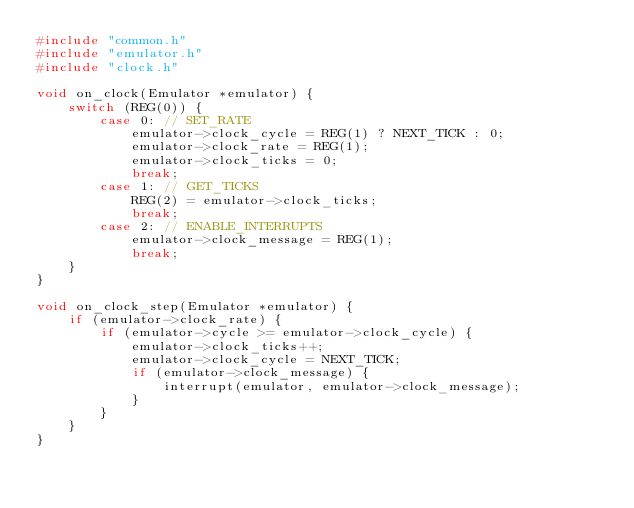Convert code to text. <code><loc_0><loc_0><loc_500><loc_500><_C_>#include "common.h"
#include "emulator.h"
#include "clock.h"

void on_clock(Emulator *emulator) {
    switch (REG(0)) {
        case 0: // SET_RATE
            emulator->clock_cycle = REG(1) ? NEXT_TICK : 0;
            emulator->clock_rate = REG(1);
            emulator->clock_ticks = 0;
            break;
        case 1: // GET_TICKS
            REG(2) = emulator->clock_ticks;
            break;
        case 2: // ENABLE_INTERRUPTS
            emulator->clock_message = REG(1);
            break;
    }
}

void on_clock_step(Emulator *emulator) {
    if (emulator->clock_rate) {
        if (emulator->cycle >= emulator->clock_cycle) {
            emulator->clock_ticks++;
            emulator->clock_cycle = NEXT_TICK;
            if (emulator->clock_message) {
                interrupt(emulator, emulator->clock_message);
            }
        }
    }
}
</code> 